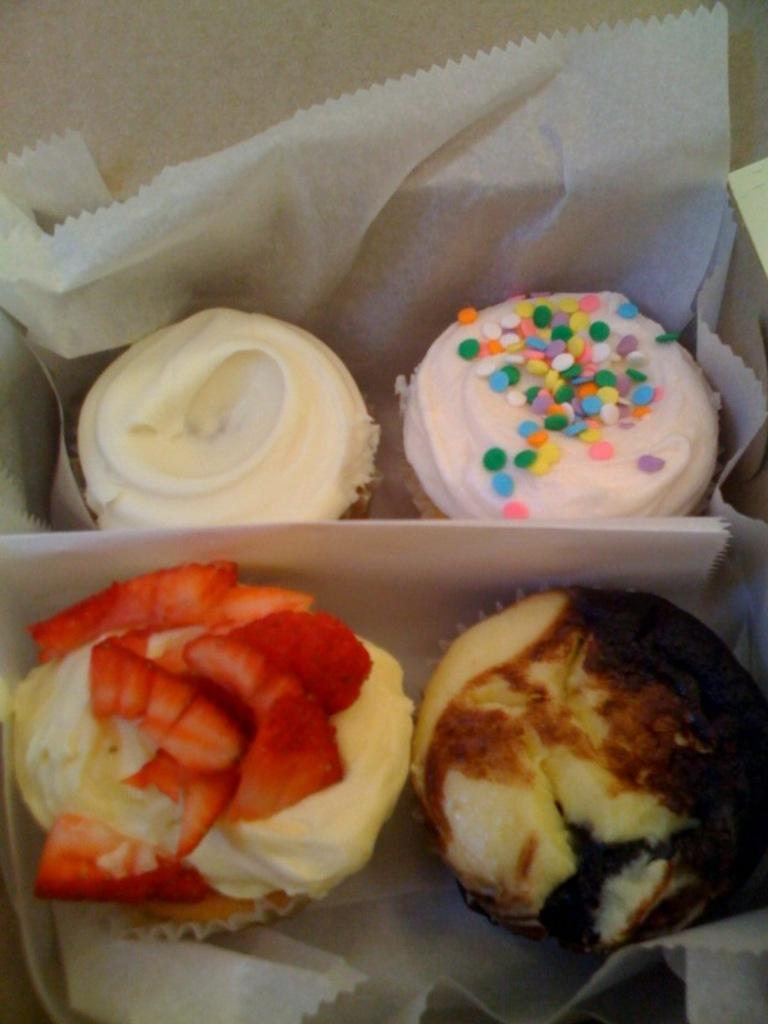What object is present in the image that can hold items? There is a box in the image that can hold items. What is inside the box in the image? The box contains four cupcakes. Are the cupcakes visible or hidden in the image? The cupcakes are inside the box, so they are not directly visible. What else can be seen in the image besides the box and cupcakes? There are tissue papers in the image. What type of locket is hanging from the cupcakes in the image? There is no locket present in the image, as it only contains cupcakes and tissue papers. What line or verse can be seen written on the tissue papers in the image? There is no line or verse written on the tissue papers in the image; they are plain. 